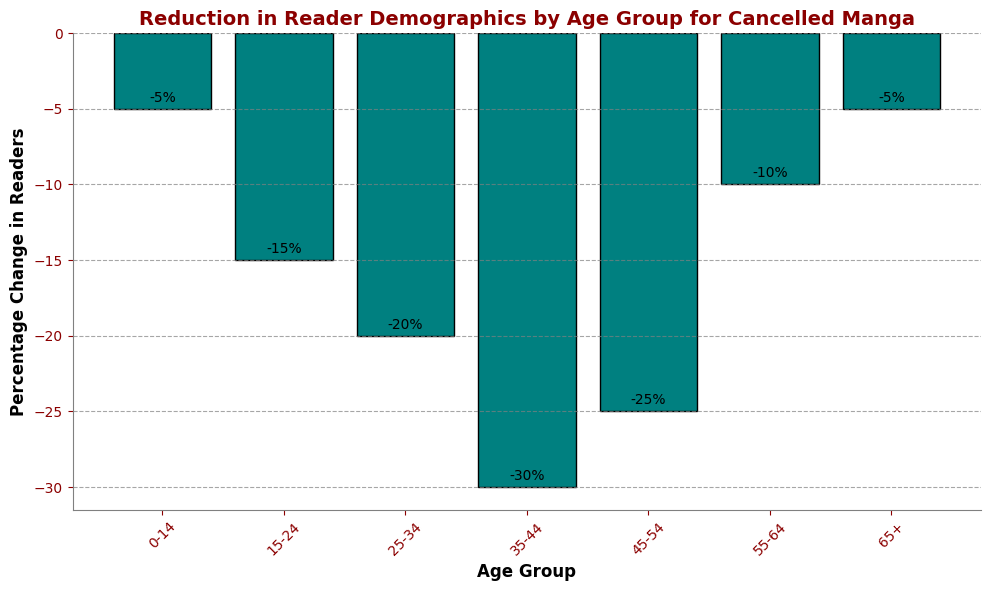What's the age group with the largest reduction in readers? Look for the bar with the greatest negative value. The bar representing the 35-44 age group has the largest negative percentage change at -30%.
Answer: 35-44 Which age groups experienced the least reduction in readers? Identify the bars that have the smallest negative value. Both the 0-14 and 65+ age groups have the smallest negative percentage changes at -5%.
Answer: 0-14 and 65+ What is the total percentage reduction in readers for the age groups 15-24 and 45-54? Sum the percentage reductions for age groups 15-24 and 45-54. The values are -15% and -25%, respectively. The total reduction is -15 + (-25) = -40%.
Answer: -40% Is the percentage reduction of readers in the 55-64 age group more than that in the 0-14 age group? Compare the bars for the 55-64 and 0-14 age groups. The percentage change for 55-64 is -10%, while for 0-14 it is -5%. Since -10% is smaller than -5%, the 55-64 group has a larger reduction.
Answer: Yes How much greater is the percentage reduction for the 35-44 age group compared to the 25-34 age group? Subtract the percentage reduction of the 25-34 age group from that of the 35-44 age group. The values are -30% and -20%, respectively. The difference is -30 - (-20) = -10%.
Answer: 10% Which two adjacent age groups have the biggest difference in percentage reduction? Examine the bars and calculate differences between adjacent age groups. The largest difference of 10% is between age groups 35-44 (-30%) and 45-54 (-25%).
Answer: 35-44 and 45-54 Is the percentage reduction for the 15-24 age group greater than the 55-64 age group? Look at the bars for 15-24 and 55-64 age groups. The values are -15% and -10%, respectively. -15% is less than -10%, so the 15-24 age group has a larger reduction.
Answer: Yes 